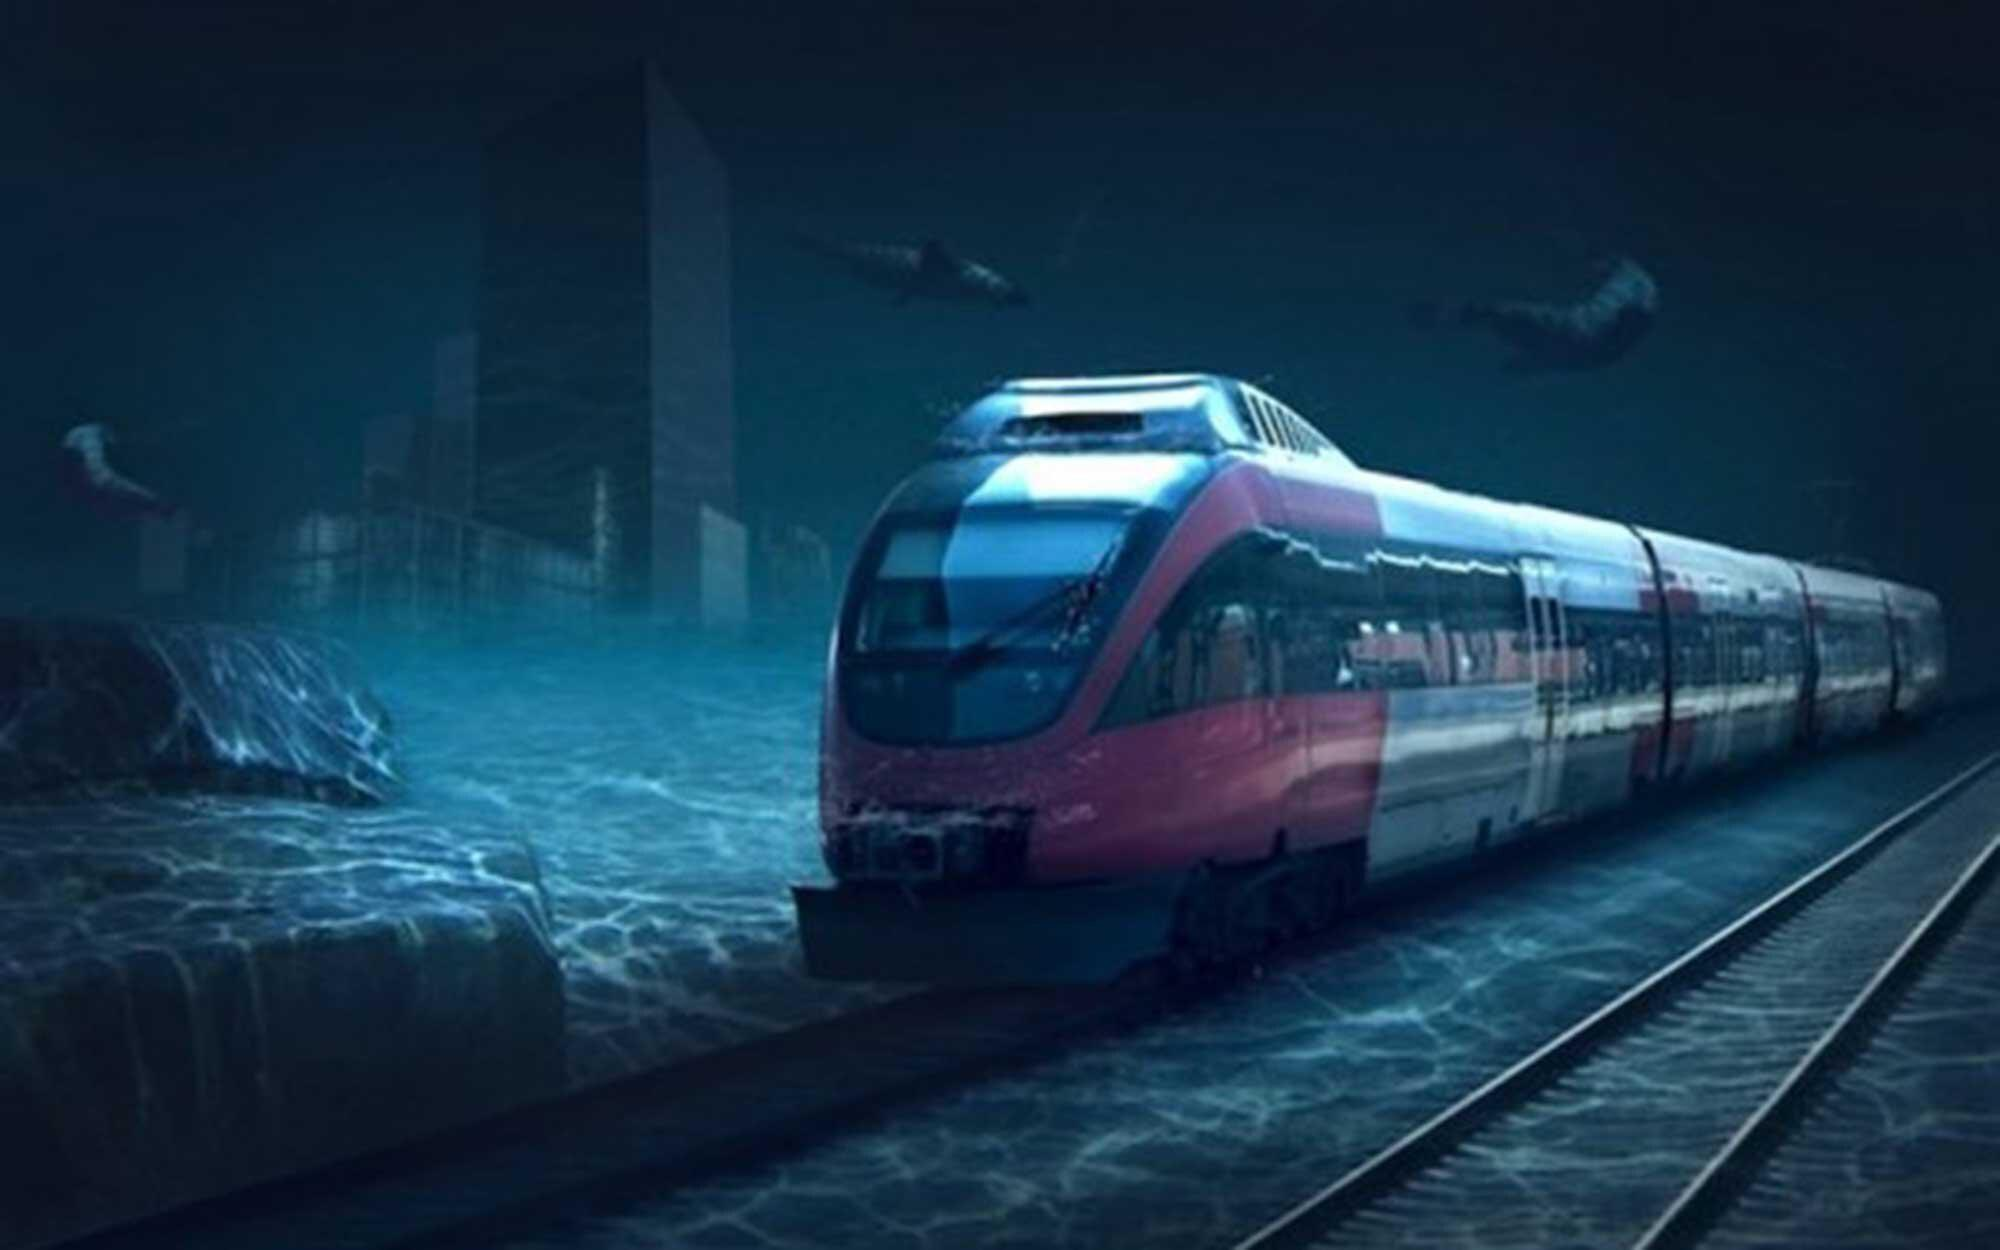Can you tell me more about the setting of this image? Certainly! The image presents an imaginative scenario where a train is traveling through an urban landscape partially submerged in water. The architecture in the background seems modern, with skyscrapers emerging from the water. This combination of elements conjures up a dystopian or perhaps post-apocalyptic story where water levels have risen, yet some semblance of modern civilization endures. 